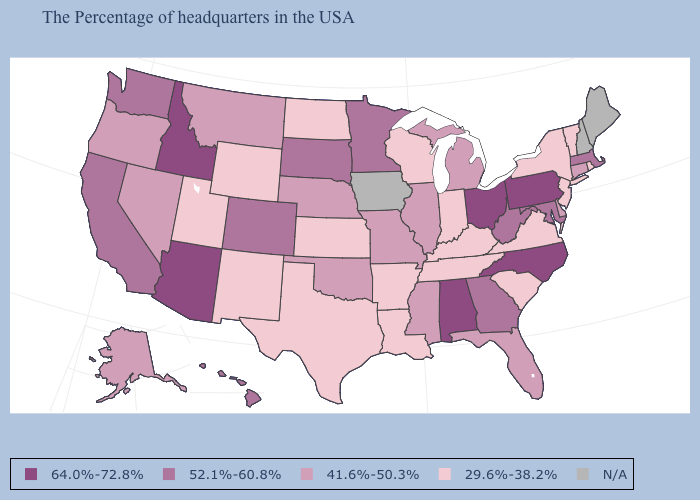Name the states that have a value in the range 41.6%-50.3%?
Quick response, please. Connecticut, Delaware, Florida, Michigan, Illinois, Mississippi, Missouri, Nebraska, Oklahoma, Montana, Nevada, Oregon, Alaska. What is the value of Illinois?
Keep it brief. 41.6%-50.3%. How many symbols are there in the legend?
Answer briefly. 5. Name the states that have a value in the range 64.0%-72.8%?
Quick response, please. Pennsylvania, North Carolina, Ohio, Alabama, Arizona, Idaho. Name the states that have a value in the range 41.6%-50.3%?
Give a very brief answer. Connecticut, Delaware, Florida, Michigan, Illinois, Mississippi, Missouri, Nebraska, Oklahoma, Montana, Nevada, Oregon, Alaska. Among the states that border Tennessee , which have the lowest value?
Keep it brief. Virginia, Kentucky, Arkansas. What is the highest value in states that border Arkansas?
Give a very brief answer. 41.6%-50.3%. Which states have the lowest value in the USA?
Keep it brief. Rhode Island, Vermont, New York, New Jersey, Virginia, South Carolina, Kentucky, Indiana, Tennessee, Wisconsin, Louisiana, Arkansas, Kansas, Texas, North Dakota, Wyoming, New Mexico, Utah. Which states have the lowest value in the USA?
Keep it brief. Rhode Island, Vermont, New York, New Jersey, Virginia, South Carolina, Kentucky, Indiana, Tennessee, Wisconsin, Louisiana, Arkansas, Kansas, Texas, North Dakota, Wyoming, New Mexico, Utah. Name the states that have a value in the range 41.6%-50.3%?
Write a very short answer. Connecticut, Delaware, Florida, Michigan, Illinois, Mississippi, Missouri, Nebraska, Oklahoma, Montana, Nevada, Oregon, Alaska. What is the highest value in states that border North Dakota?
Give a very brief answer. 52.1%-60.8%. Name the states that have a value in the range 64.0%-72.8%?
Concise answer only. Pennsylvania, North Carolina, Ohio, Alabama, Arizona, Idaho. What is the value of Mississippi?
Give a very brief answer. 41.6%-50.3%. Among the states that border West Virginia , which have the lowest value?
Answer briefly. Virginia, Kentucky. 